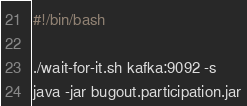<code> <loc_0><loc_0><loc_500><loc_500><_Bash_>#!/bin/bash

./wait-for-it.sh kafka:9092 -s
java -jar bugout.participation.jar
</code> 